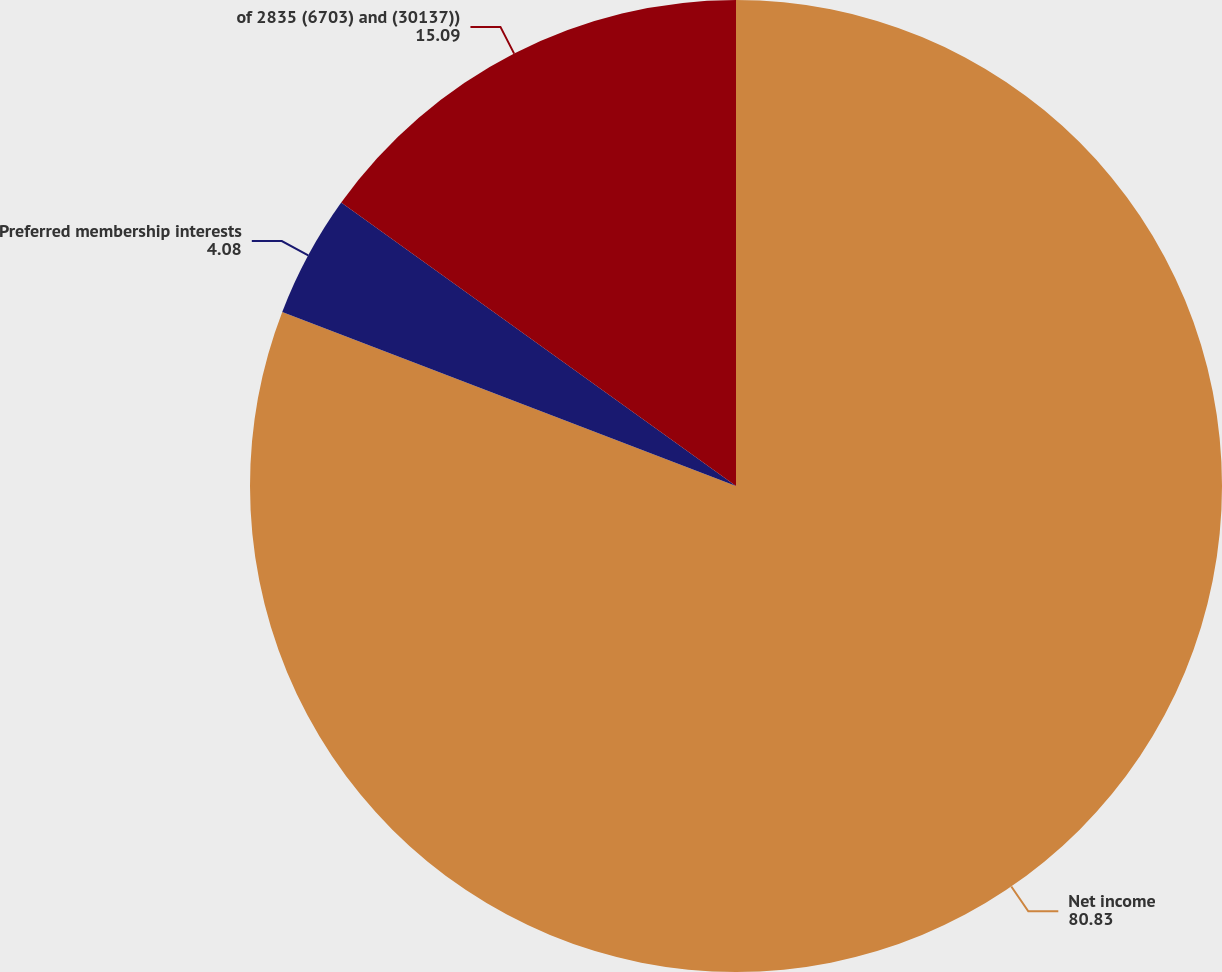Convert chart. <chart><loc_0><loc_0><loc_500><loc_500><pie_chart><fcel>Net income<fcel>Preferred membership interests<fcel>of 2835 (6703) and (30137))<nl><fcel>80.83%<fcel>4.08%<fcel>15.09%<nl></chart> 